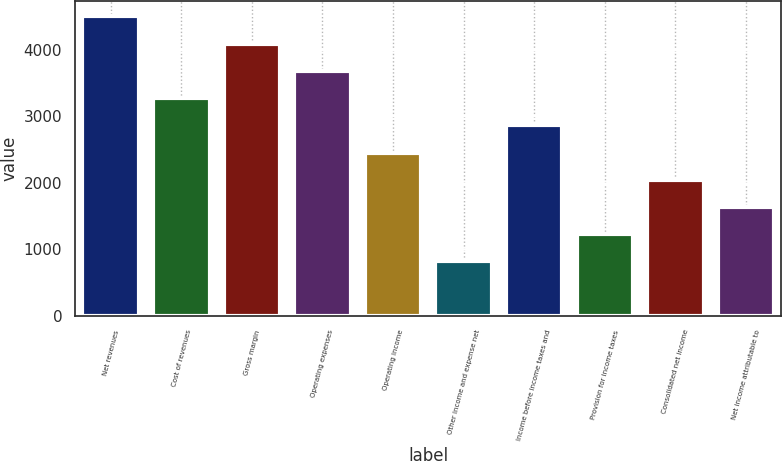<chart> <loc_0><loc_0><loc_500><loc_500><bar_chart><fcel>Net revenues<fcel>Cost of revenues<fcel>Gross margin<fcel>Operating expenses<fcel>Operating income<fcel>Other income and expense net<fcel>Income before income taxes and<fcel>Provision for income taxes<fcel>Consolidated net income<fcel>Net income attributable to<nl><fcel>4502.53<fcel>3274.88<fcel>4093.32<fcel>3684.1<fcel>2456.45<fcel>819.59<fcel>2865.66<fcel>1228.81<fcel>2047.24<fcel>1638.03<nl></chart> 